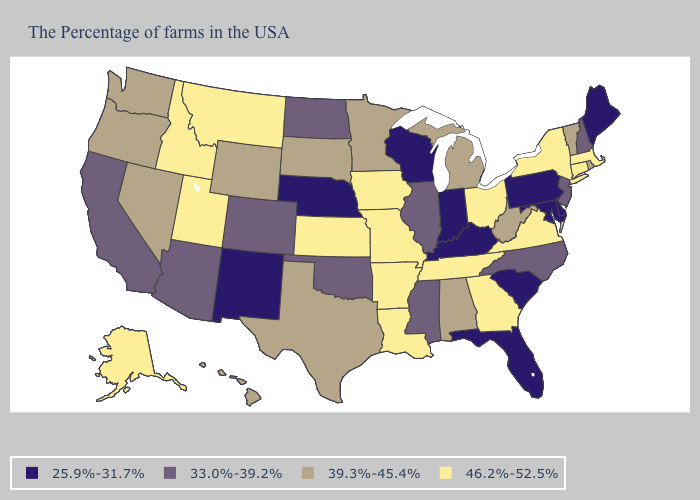Name the states that have a value in the range 46.2%-52.5%?
Concise answer only. Massachusetts, Connecticut, New York, Virginia, Ohio, Georgia, Tennessee, Louisiana, Missouri, Arkansas, Iowa, Kansas, Utah, Montana, Idaho, Alaska. Which states have the lowest value in the USA?
Give a very brief answer. Maine, Delaware, Maryland, Pennsylvania, South Carolina, Florida, Kentucky, Indiana, Wisconsin, Nebraska, New Mexico. Name the states that have a value in the range 25.9%-31.7%?
Concise answer only. Maine, Delaware, Maryland, Pennsylvania, South Carolina, Florida, Kentucky, Indiana, Wisconsin, Nebraska, New Mexico. How many symbols are there in the legend?
Answer briefly. 4. What is the highest value in the Northeast ?
Quick response, please. 46.2%-52.5%. What is the value of South Dakota?
Keep it brief. 39.3%-45.4%. Among the states that border West Virginia , does Ohio have the highest value?
Give a very brief answer. Yes. Does Nevada have the highest value in the West?
Write a very short answer. No. Does the map have missing data?
Be succinct. No. How many symbols are there in the legend?
Be succinct. 4. Does Illinois have the highest value in the USA?
Keep it brief. No. Which states have the lowest value in the USA?
Short answer required. Maine, Delaware, Maryland, Pennsylvania, South Carolina, Florida, Kentucky, Indiana, Wisconsin, Nebraska, New Mexico. Name the states that have a value in the range 25.9%-31.7%?
Quick response, please. Maine, Delaware, Maryland, Pennsylvania, South Carolina, Florida, Kentucky, Indiana, Wisconsin, Nebraska, New Mexico. Name the states that have a value in the range 25.9%-31.7%?
Concise answer only. Maine, Delaware, Maryland, Pennsylvania, South Carolina, Florida, Kentucky, Indiana, Wisconsin, Nebraska, New Mexico. Name the states that have a value in the range 25.9%-31.7%?
Quick response, please. Maine, Delaware, Maryland, Pennsylvania, South Carolina, Florida, Kentucky, Indiana, Wisconsin, Nebraska, New Mexico. 